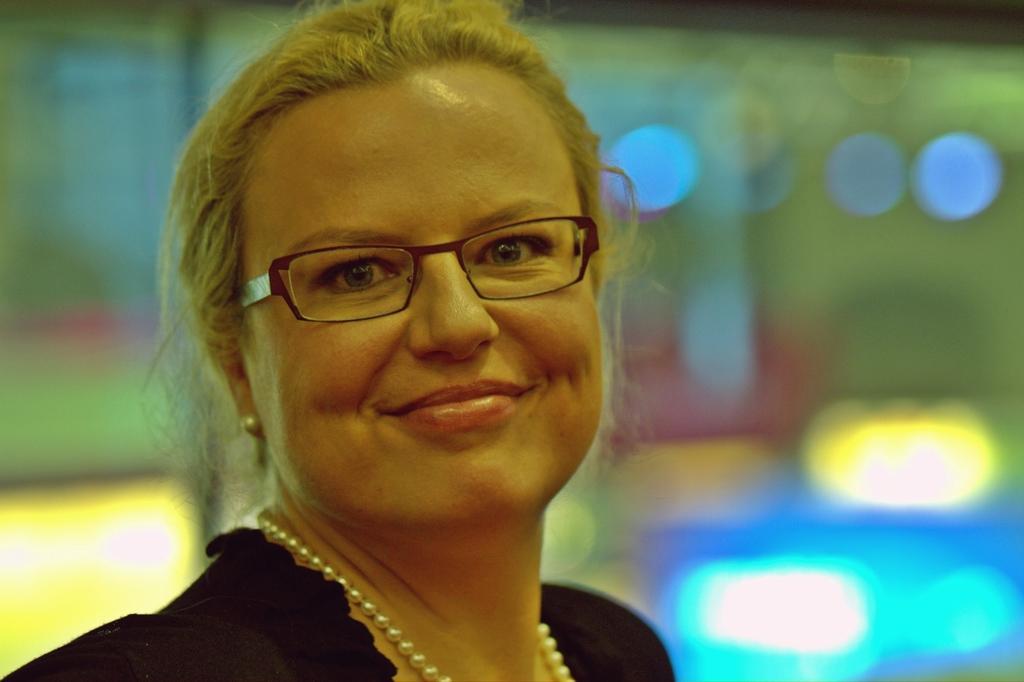Describe this image in one or two sentences. In this image I can see the person with the black color dress and specs. I can see the blurred background. 